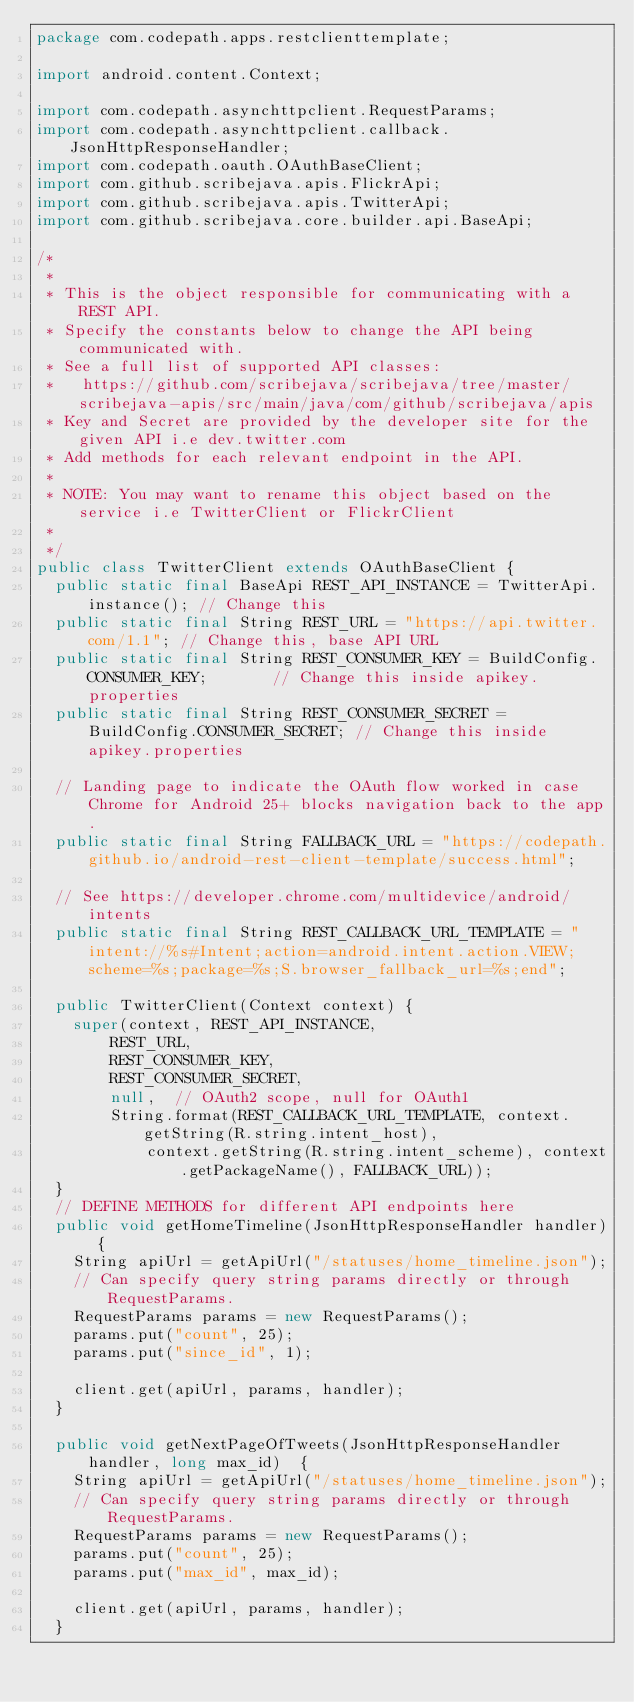Convert code to text. <code><loc_0><loc_0><loc_500><loc_500><_Java_>package com.codepath.apps.restclienttemplate;

import android.content.Context;

import com.codepath.asynchttpclient.RequestParams;
import com.codepath.asynchttpclient.callback.JsonHttpResponseHandler;
import com.codepath.oauth.OAuthBaseClient;
import com.github.scribejava.apis.FlickrApi;
import com.github.scribejava.apis.TwitterApi;
import com.github.scribejava.core.builder.api.BaseApi;

/*
 * 
 * This is the object responsible for communicating with a REST API. 
 * Specify the constants below to change the API being communicated with.
 * See a full list of supported API classes: 
 *   https://github.com/scribejava/scribejava/tree/master/scribejava-apis/src/main/java/com/github/scribejava/apis
 * Key and Secret are provided by the developer site for the given API i.e dev.twitter.com
 * Add methods for each relevant endpoint in the API.
 * 
 * NOTE: You may want to rename this object based on the service i.e TwitterClient or FlickrClient
 * 
 */
public class TwitterClient extends OAuthBaseClient {
	public static final BaseApi REST_API_INSTANCE = TwitterApi.instance(); // Change this
	public static final String REST_URL = "https://api.twitter.com/1.1"; // Change this, base API URL
	public static final String REST_CONSUMER_KEY = BuildConfig.CONSUMER_KEY;       // Change this inside apikey.properties
	public static final String REST_CONSUMER_SECRET = BuildConfig.CONSUMER_SECRET; // Change this inside apikey.properties

	// Landing page to indicate the OAuth flow worked in case Chrome for Android 25+ blocks navigation back to the app.
	public static final String FALLBACK_URL = "https://codepath.github.io/android-rest-client-template/success.html";

	// See https://developer.chrome.com/multidevice/android/intents
	public static final String REST_CALLBACK_URL_TEMPLATE = "intent://%s#Intent;action=android.intent.action.VIEW;scheme=%s;package=%s;S.browser_fallback_url=%s;end";

	public TwitterClient(Context context) {
		super(context, REST_API_INSTANCE,
				REST_URL,
				REST_CONSUMER_KEY,
				REST_CONSUMER_SECRET,
				null,  // OAuth2 scope, null for OAuth1
				String.format(REST_CALLBACK_URL_TEMPLATE, context.getString(R.string.intent_host),
						context.getString(R.string.intent_scheme), context.getPackageName(), FALLBACK_URL));
	}
	// DEFINE METHODS for different API endpoints here
	public void getHomeTimeline(JsonHttpResponseHandler handler) {
		String apiUrl = getApiUrl("/statuses/home_timeline.json");
		// Can specify query string params directly or through RequestParams.
		RequestParams params = new RequestParams();
		params.put("count", 25);
		params.put("since_id", 1);

		client.get(apiUrl, params, handler);
	}

	public void getNextPageOfTweets(JsonHttpResponseHandler handler, long max_id)  {
		String apiUrl = getApiUrl("/statuses/home_timeline.json");
		// Can specify query string params directly or through RequestParams.
		RequestParams params = new RequestParams();
		params.put("count", 25);
		params.put("max_id", max_id);

		client.get(apiUrl, params, handler);
	}
</code> 